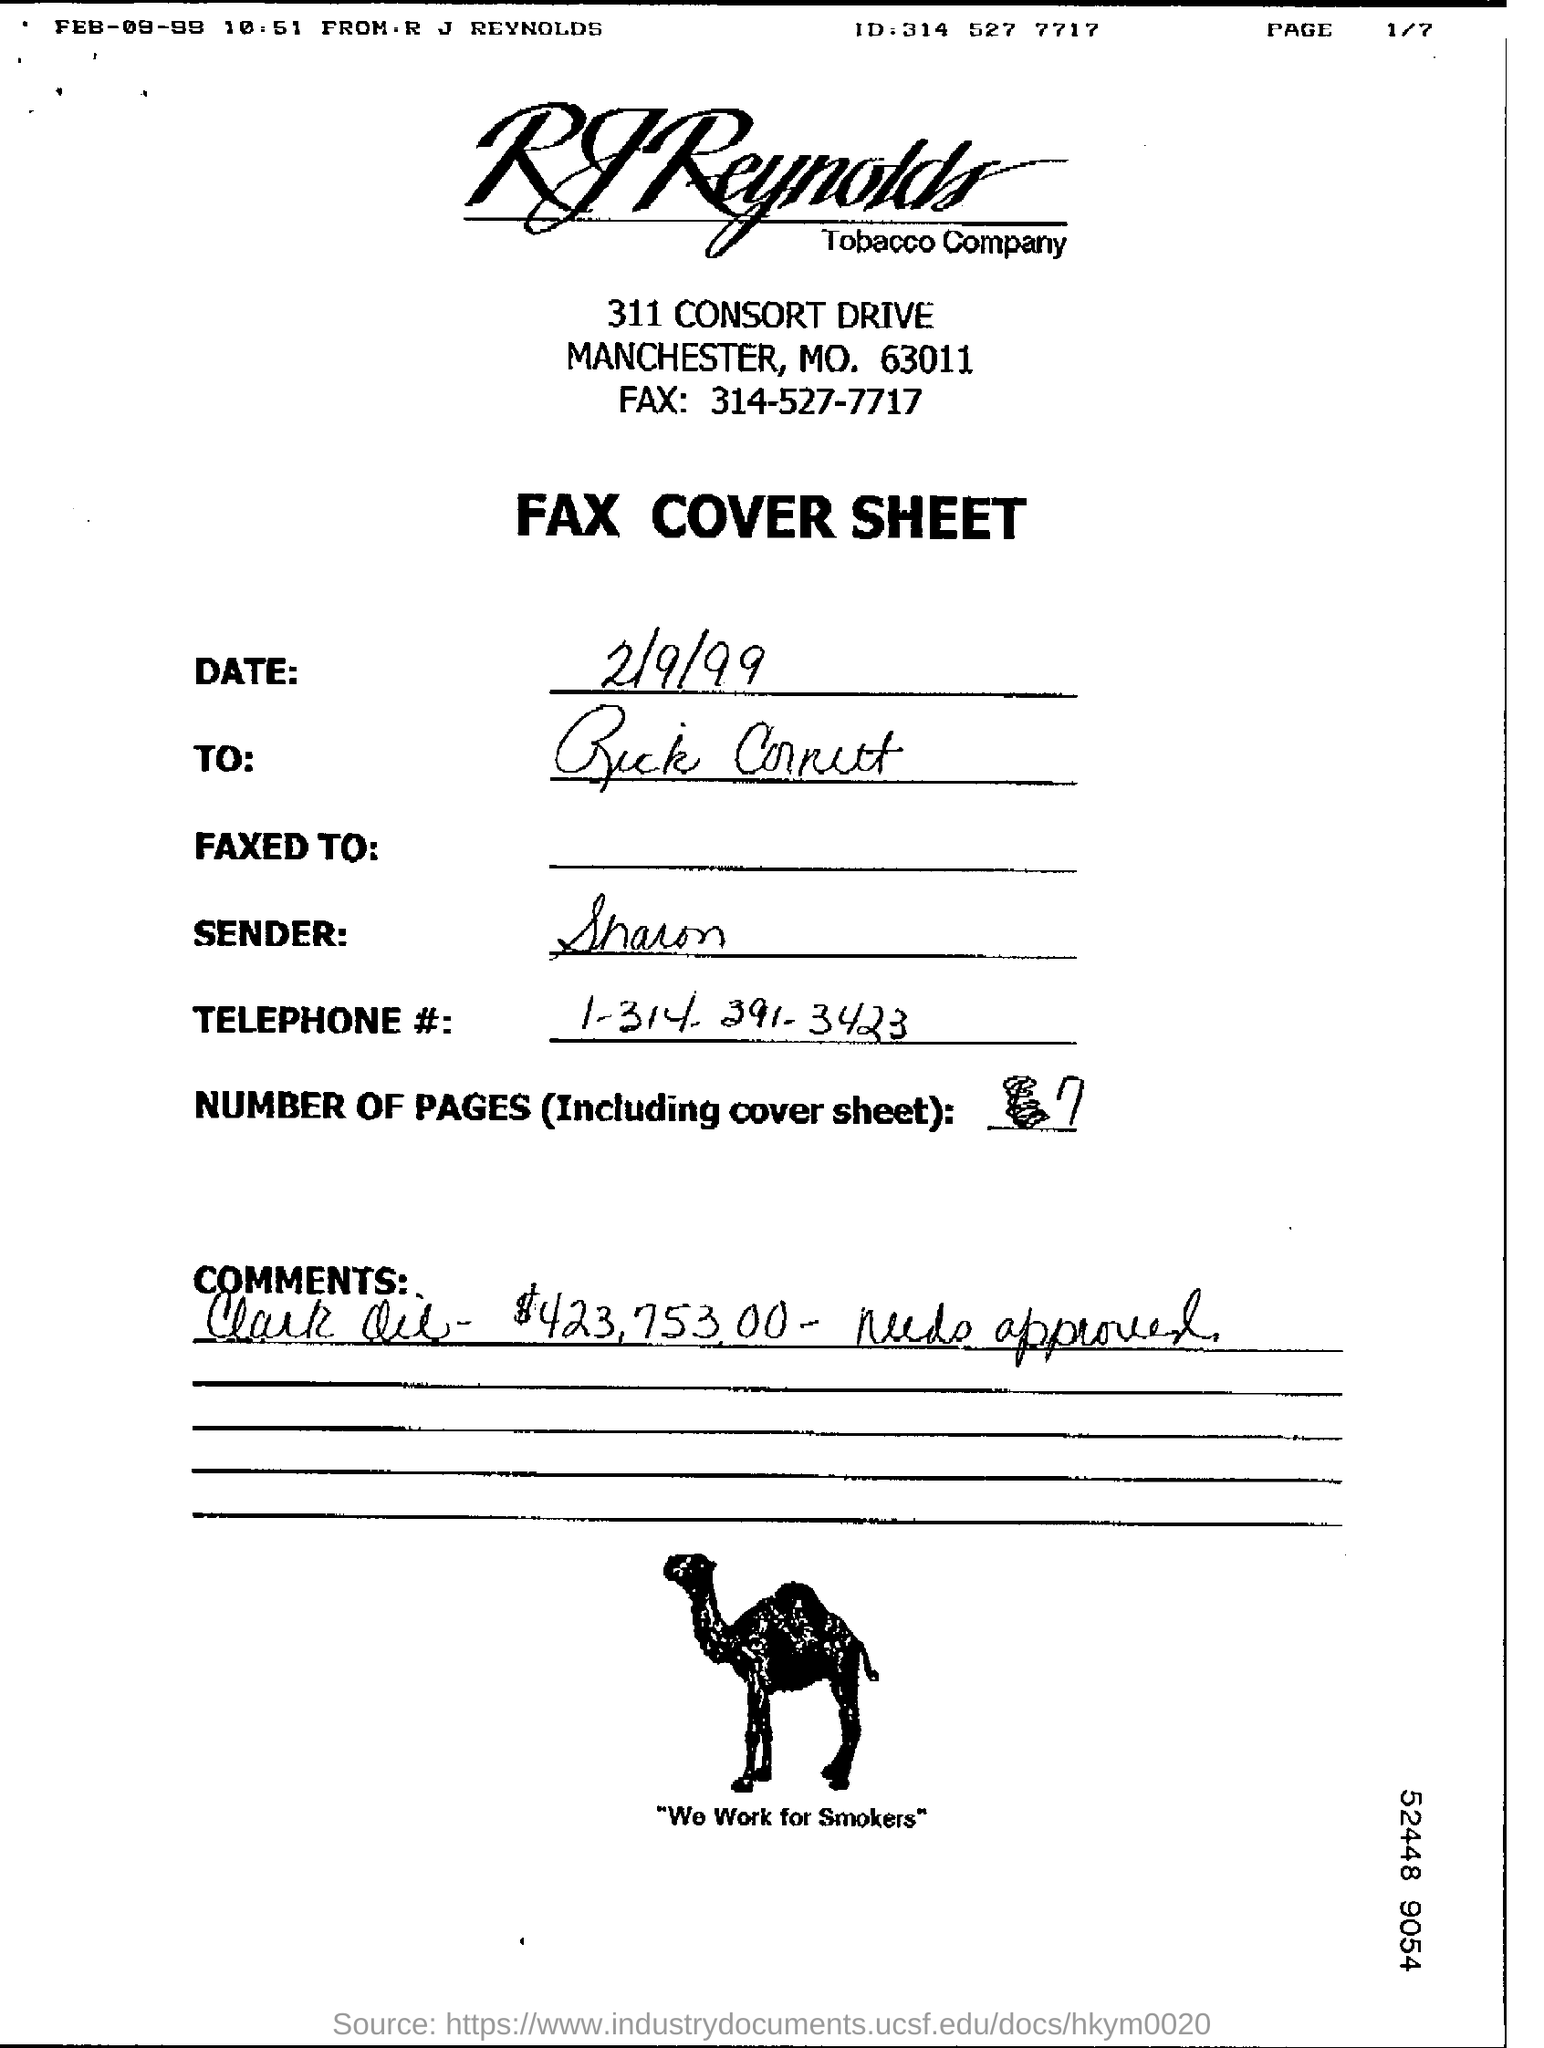Highlight a few significant elements in this photo. The sender is Sharon. The total number of pages, including the cover sheet, is 7. 